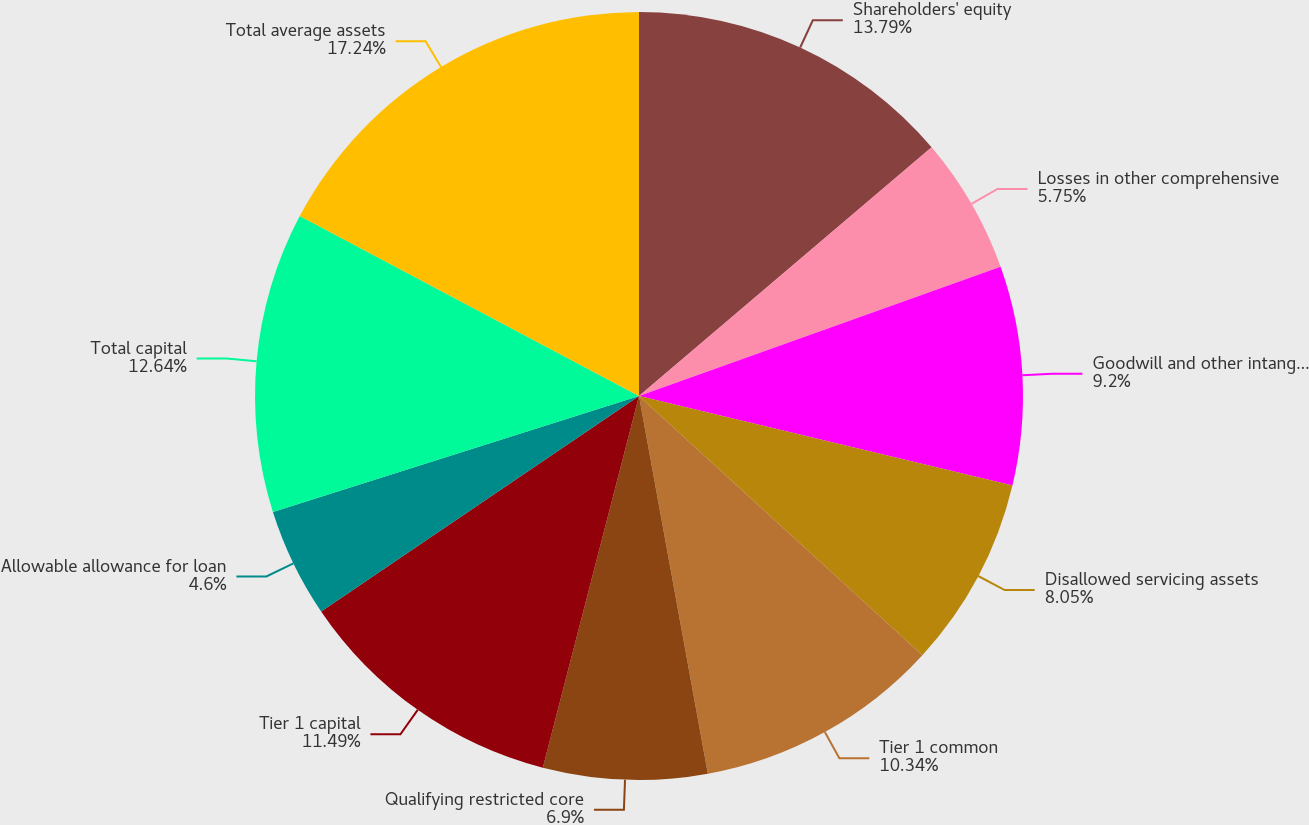Convert chart. <chart><loc_0><loc_0><loc_500><loc_500><pie_chart><fcel>Shareholders' equity<fcel>Losses in other comprehensive<fcel>Goodwill and other intangible<fcel>Disallowed servicing assets<fcel>Tier 1 common<fcel>Qualifying restricted core<fcel>Tier 1 capital<fcel>Allowable allowance for loan<fcel>Total capital<fcel>Total average assets<nl><fcel>13.79%<fcel>5.75%<fcel>9.2%<fcel>8.05%<fcel>10.34%<fcel>6.9%<fcel>11.49%<fcel>4.6%<fcel>12.64%<fcel>17.24%<nl></chart> 